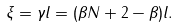<formula> <loc_0><loc_0><loc_500><loc_500>\xi = \gamma l = ( \beta N + 2 - \beta ) l .</formula> 